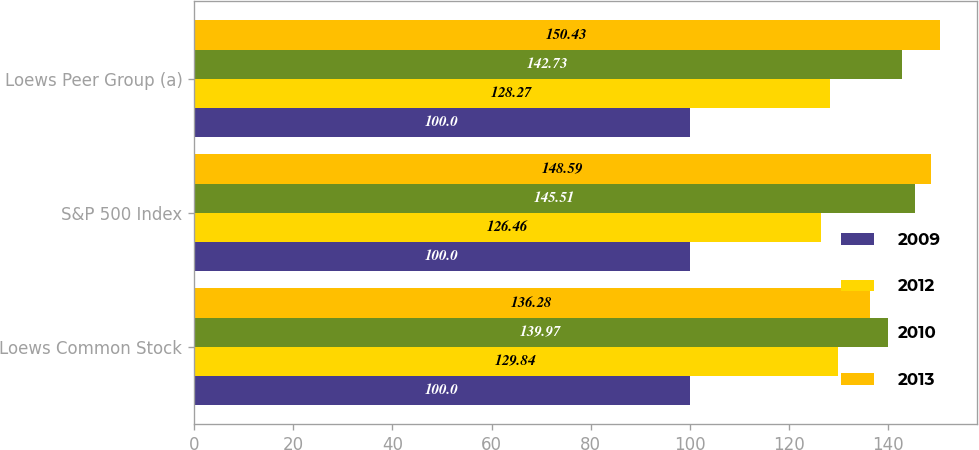<chart> <loc_0><loc_0><loc_500><loc_500><stacked_bar_chart><ecel><fcel>Loews Common Stock<fcel>S&P 500 Index<fcel>Loews Peer Group (a)<nl><fcel>2009<fcel>100<fcel>100<fcel>100<nl><fcel>2012<fcel>129.84<fcel>126.46<fcel>128.27<nl><fcel>2010<fcel>139.97<fcel>145.51<fcel>142.73<nl><fcel>2013<fcel>136.28<fcel>148.59<fcel>150.43<nl></chart> 